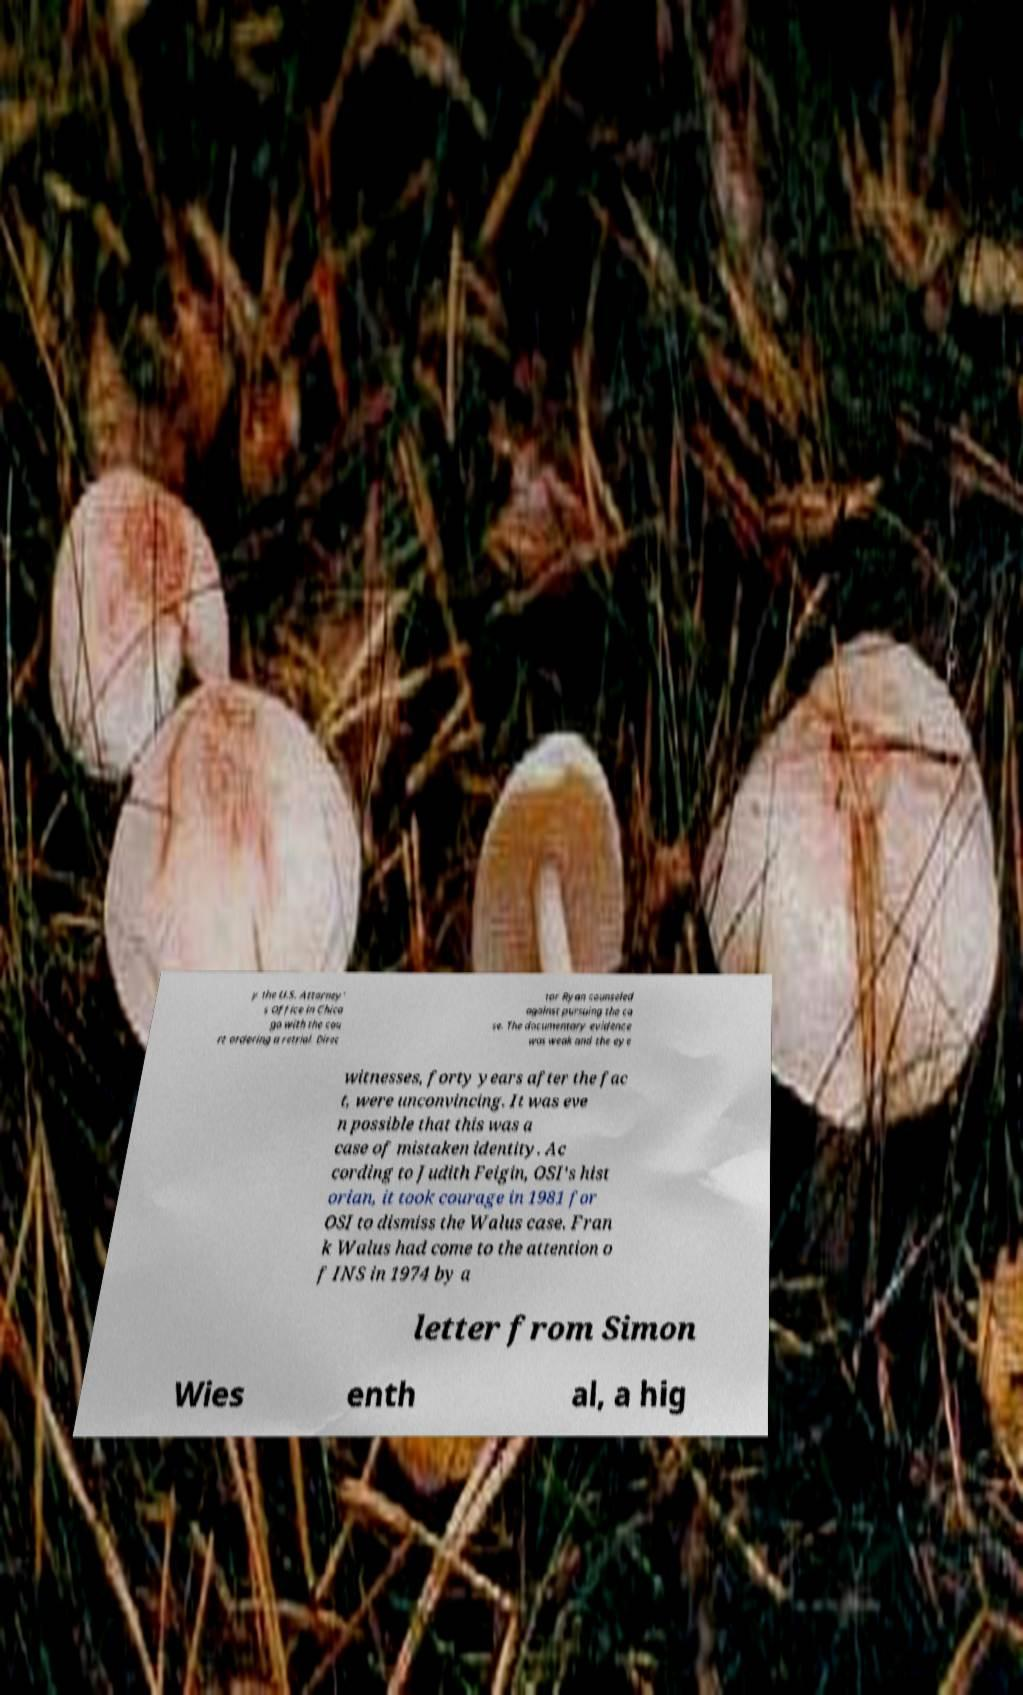Please read and relay the text visible in this image. What does it say? y the U.S. Attorney' s Office in Chica go with the cou rt ordering a retrial. Direc tor Ryan counseled against pursuing the ca se. The documentary evidence was weak and the eye witnesses, forty years after the fac t, were unconvincing. It was eve n possible that this was a case of mistaken identity. Ac cording to Judith Feigin, OSI's hist orian, it took courage in 1981 for OSI to dismiss the Walus case. Fran k Walus had come to the attention o f INS in 1974 by a letter from Simon Wies enth al, a hig 